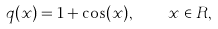<formula> <loc_0><loc_0><loc_500><loc_500>q ( x ) = 1 + \cos ( x ) , \quad x \in R ,</formula> 